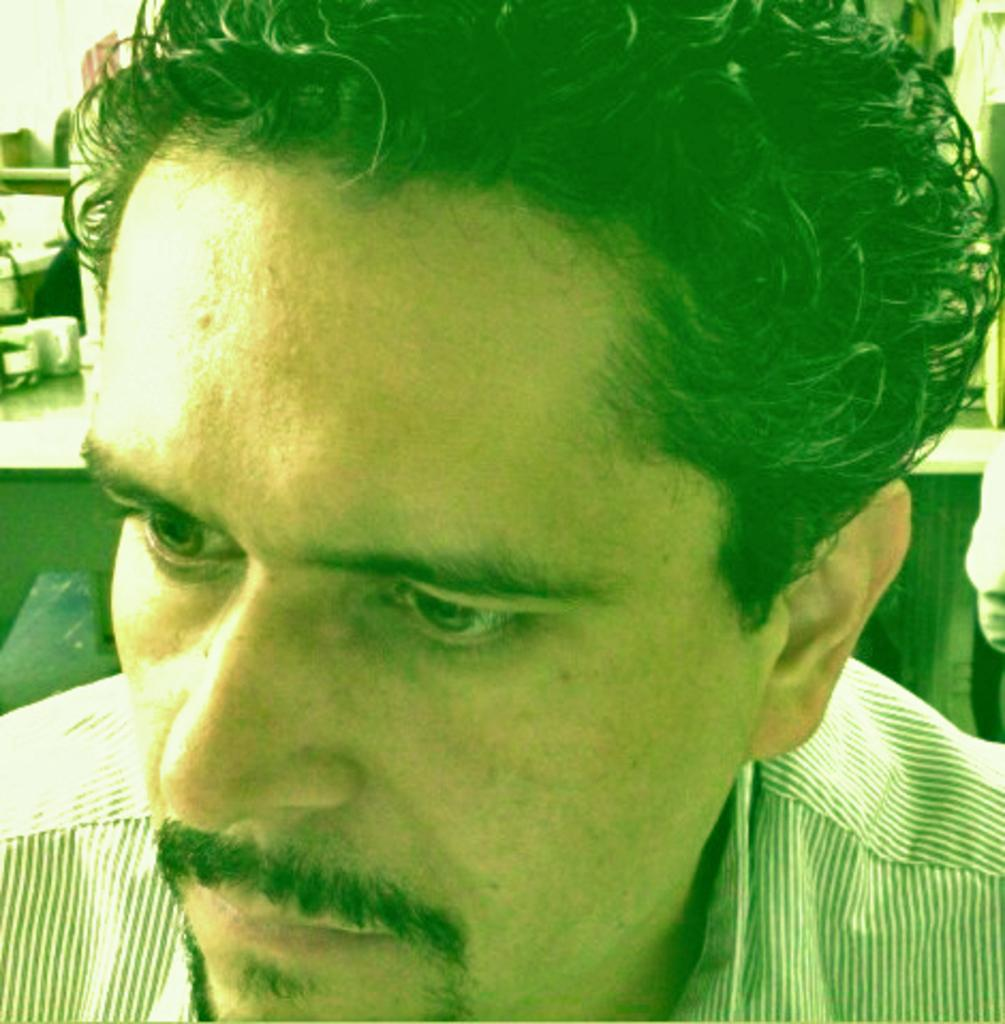Who is present in the image? There is a man in the image. What can be seen in the background of the image? There are objects in the background of the image. What type of wood can be tasted in the image? There is no wood present in the image, and therefore no taste can be associated with it. 